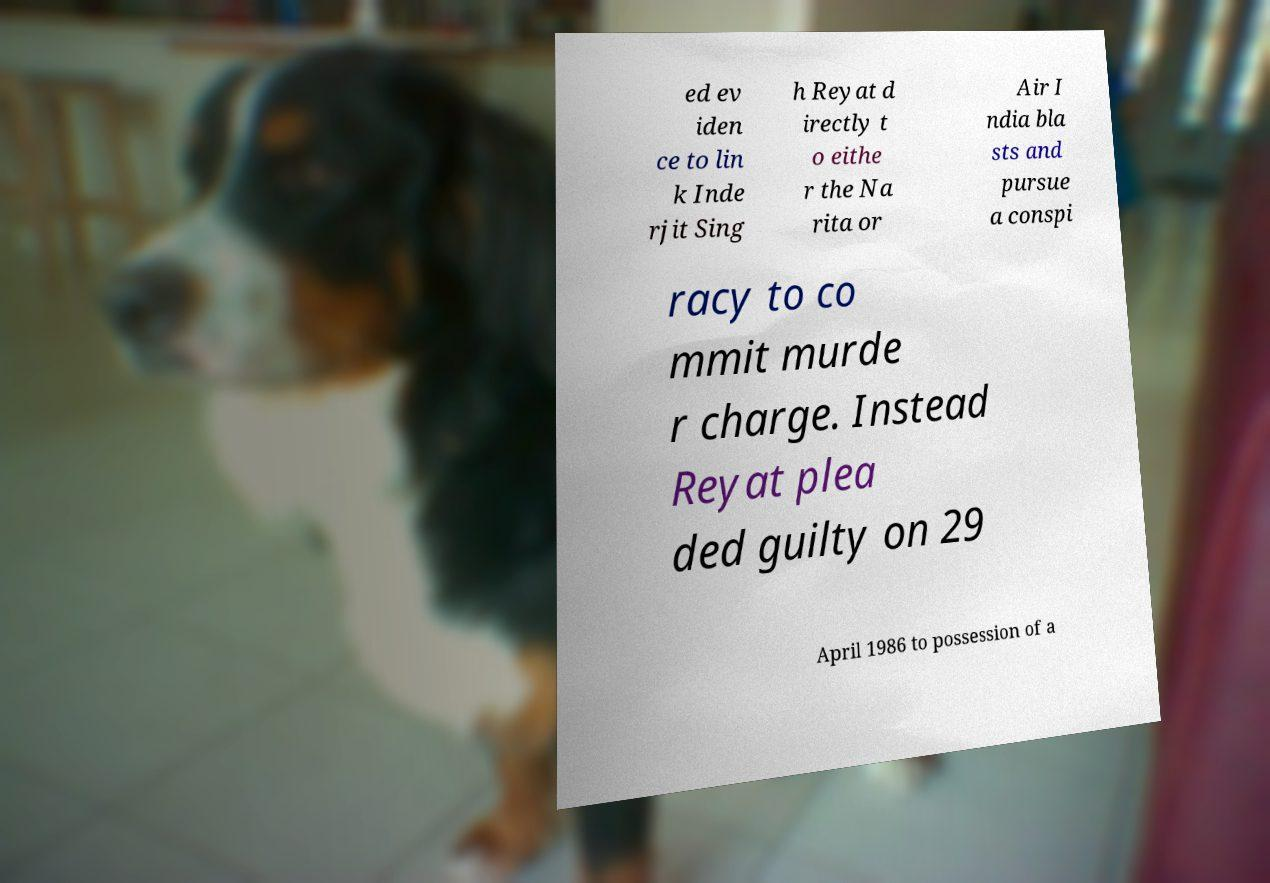What messages or text are displayed in this image? I need them in a readable, typed format. ed ev iden ce to lin k Inde rjit Sing h Reyat d irectly t o eithe r the Na rita or Air I ndia bla sts and pursue a conspi racy to co mmit murde r charge. Instead Reyat plea ded guilty on 29 April 1986 to possession of a 